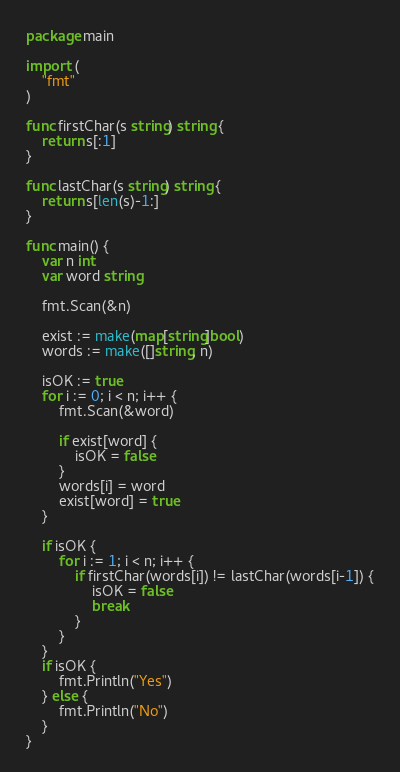Convert code to text. <code><loc_0><loc_0><loc_500><loc_500><_Go_>package main

import (
	"fmt"
)

func firstChar(s string) string {
	return s[:1]
}

func lastChar(s string) string {
	return s[len(s)-1:]
}

func main() {
	var n int
	var word string

	fmt.Scan(&n)

	exist := make(map[string]bool)
	words := make([]string, n)

	isOK := true
	for i := 0; i < n; i++ {
		fmt.Scan(&word)

		if exist[word] {
			isOK = false
		}
		words[i] = word
		exist[word] = true
	}

	if isOK {
		for i := 1; i < n; i++ {
			if firstChar(words[i]) != lastChar(words[i-1]) {
				isOK = false
				break
			}
		}
	}
	if isOK {
		fmt.Println("Yes")
	} else {
		fmt.Println("No")
	}
}
</code> 